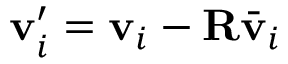<formula> <loc_0><loc_0><loc_500><loc_500>v _ { i } ^ { \prime } = v _ { i } - R \bar { v } _ { i }</formula> 